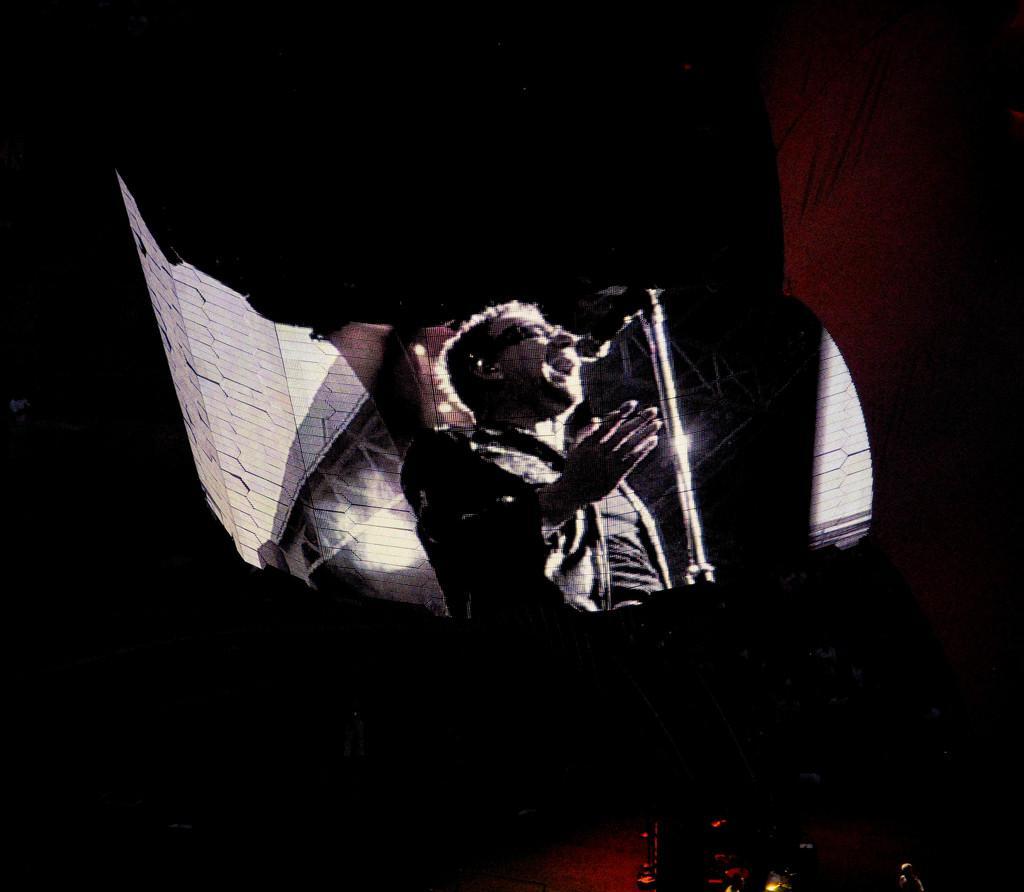Describe this image in one or two sentences. There is a screen. On that there is a person singing song. In front of him there is a mic and mic stand. In the background it is blurred. 